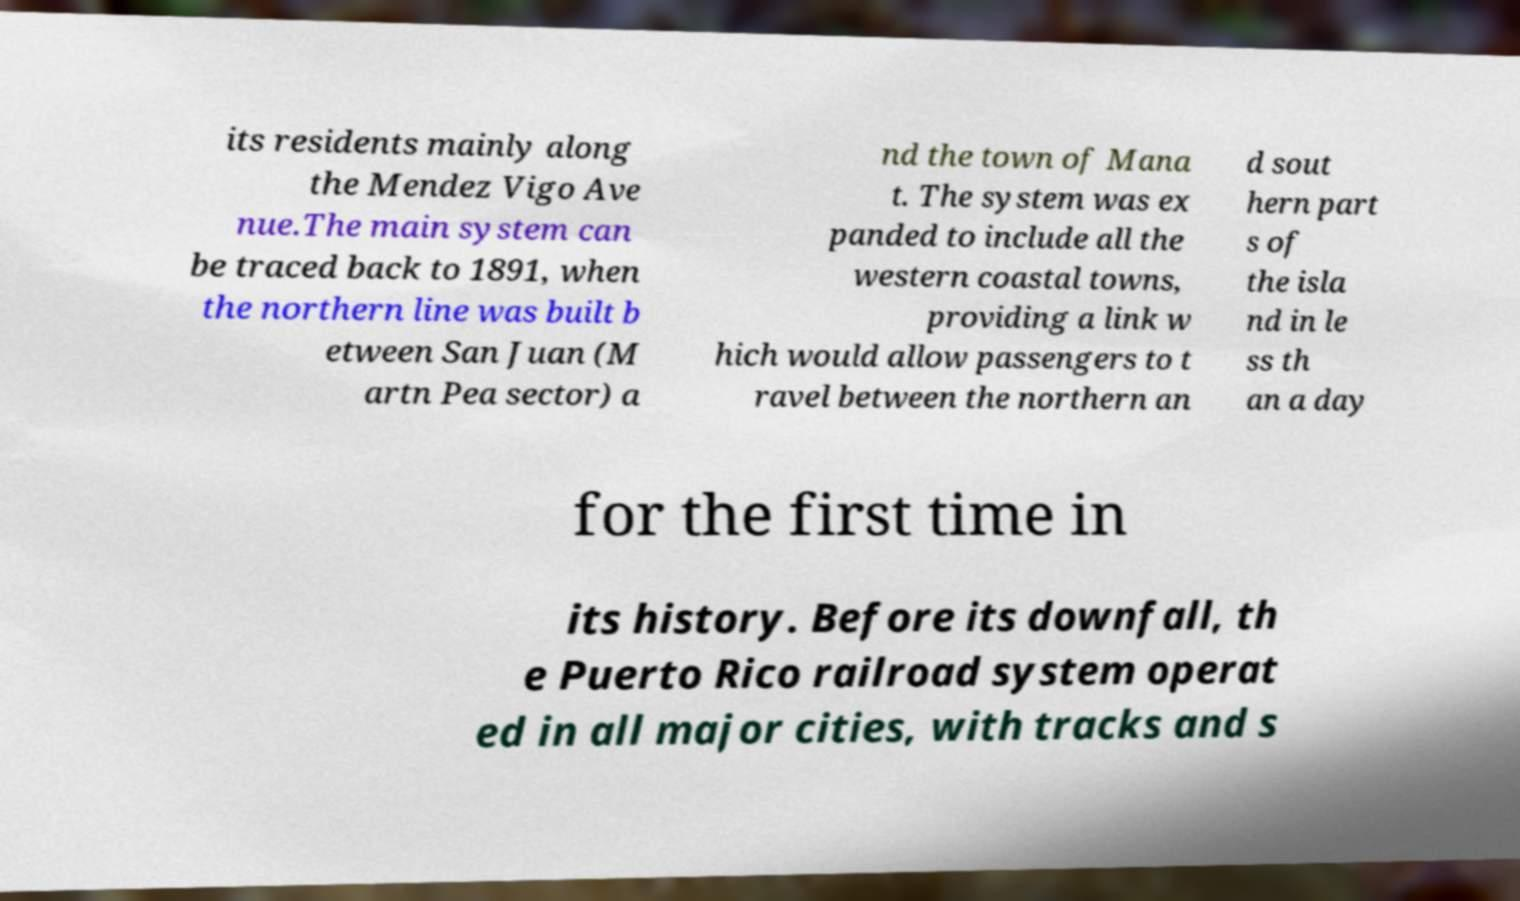Please identify and transcribe the text found in this image. its residents mainly along the Mendez Vigo Ave nue.The main system can be traced back to 1891, when the northern line was built b etween San Juan (M artn Pea sector) a nd the town of Mana t. The system was ex panded to include all the western coastal towns, providing a link w hich would allow passengers to t ravel between the northern an d sout hern part s of the isla nd in le ss th an a day for the first time in its history. Before its downfall, th e Puerto Rico railroad system operat ed in all major cities, with tracks and s 